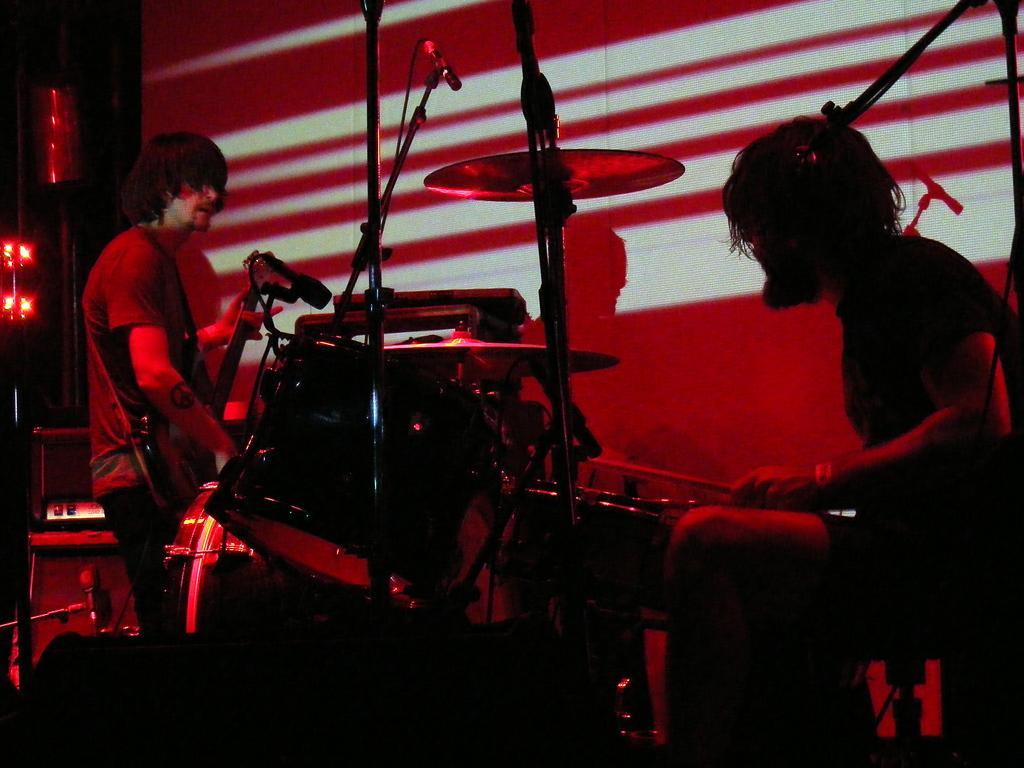Please provide a concise description of this image. In the foreground of the picture there is a person playing drums. In the center of the picture there are microphones. On the left there are music control system, lights, microphone and a person playing guitar. 